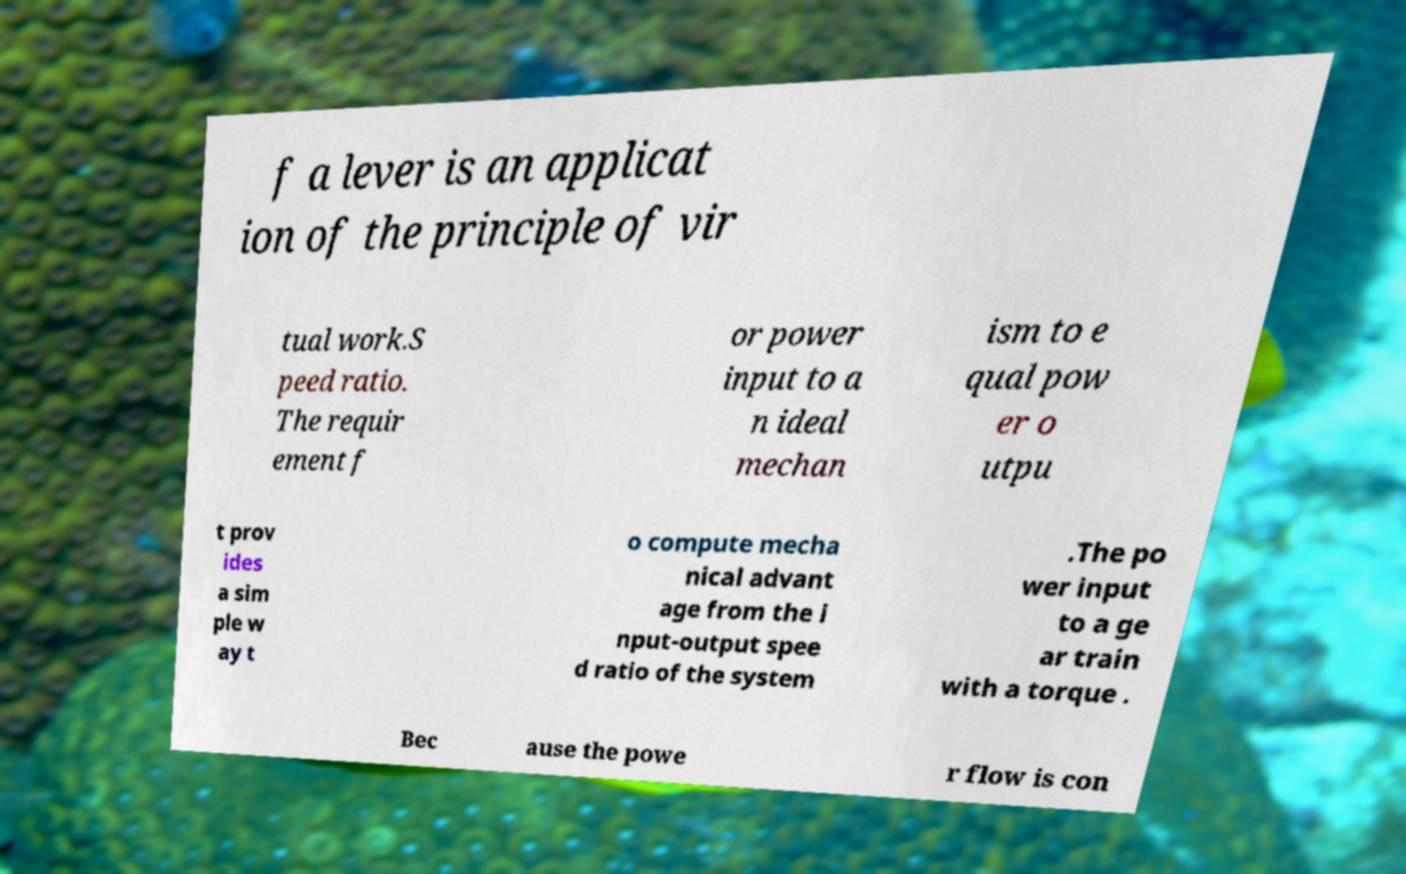For documentation purposes, I need the text within this image transcribed. Could you provide that? f a lever is an applicat ion of the principle of vir tual work.S peed ratio. The requir ement f or power input to a n ideal mechan ism to e qual pow er o utpu t prov ides a sim ple w ay t o compute mecha nical advant age from the i nput-output spee d ratio of the system .The po wer input to a ge ar train with a torque . Bec ause the powe r flow is con 